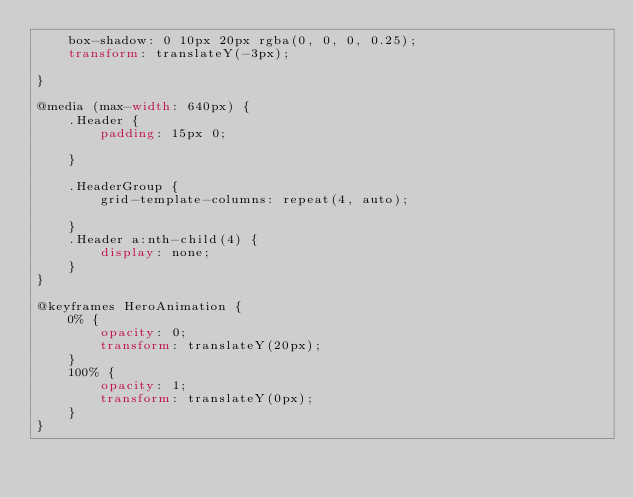<code> <loc_0><loc_0><loc_500><loc_500><_CSS_>    box-shadow: 0 10px 20px rgba(0, 0, 0, 0.25);
    transform: translateY(-3px);

}

@media (max-width: 640px) {
    .Header {
        padding: 15px 0;

    }

    .HeaderGroup {
        grid-template-columns: repeat(4, auto);

    }
    .Header a:nth-child(4) {
        display: none;
    }
} 

@keyframes HeroAnimation {
    0% {
        opacity: 0;
        transform: translateY(20px);
    }
    100% {
        opacity: 1;
        transform: translateY(0px);
    }
}</code> 